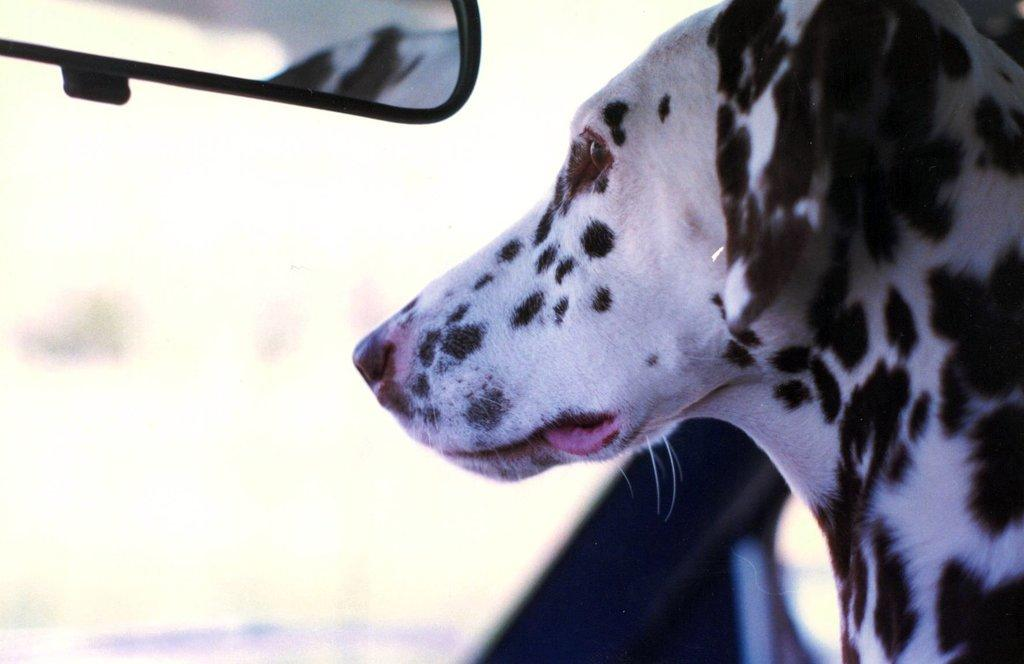What type of animal is in the image? There is a dog in the image. Can you describe the color pattern of the dog? The dog has a white and black color pattern. What object can be seen in the image besides the dog? There is a mirror visible in the image. Can you tell me how many locks are on the island in the image? There is no island or locks present in the image; it features a dog and a mirror. 